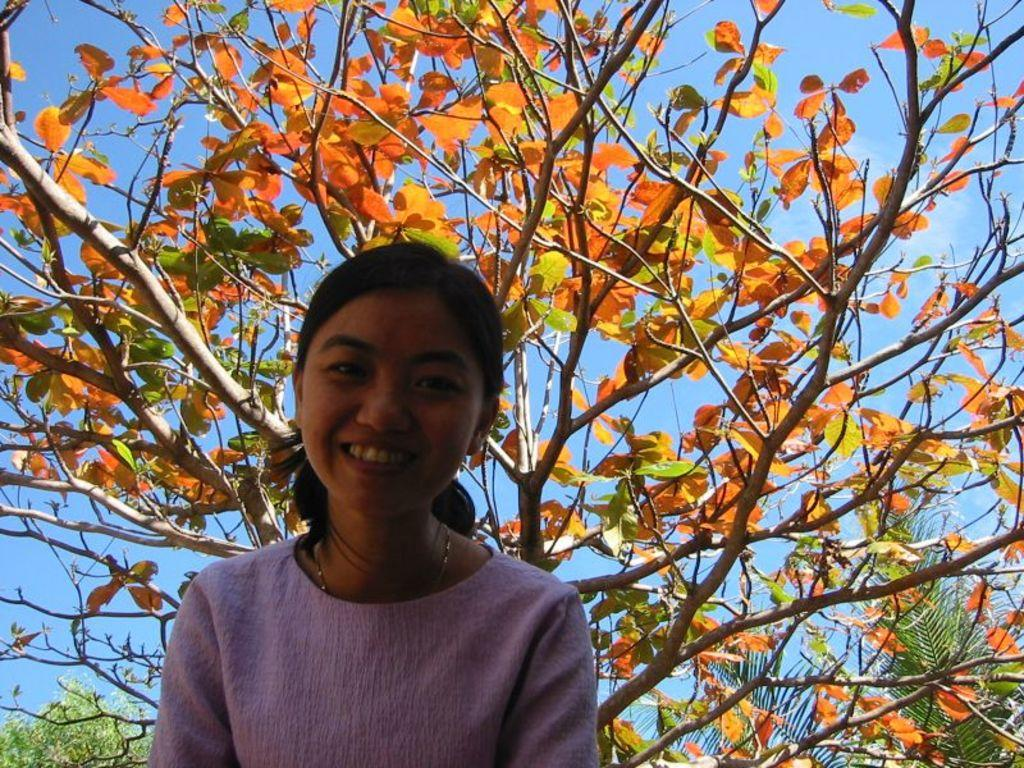Who is present in the image? There is a woman in the image. What is the woman wearing? The woman is wearing a pink dress. What expression does the woman have? The woman is smiling. What can be seen in the background of the image? There are different types of trees in the background of the image. What is visible at the top of the image? The sky is visible at the top of the image. Can you see a kitten wearing a crown in the image? No, there is no kitten or crown present in the image. 